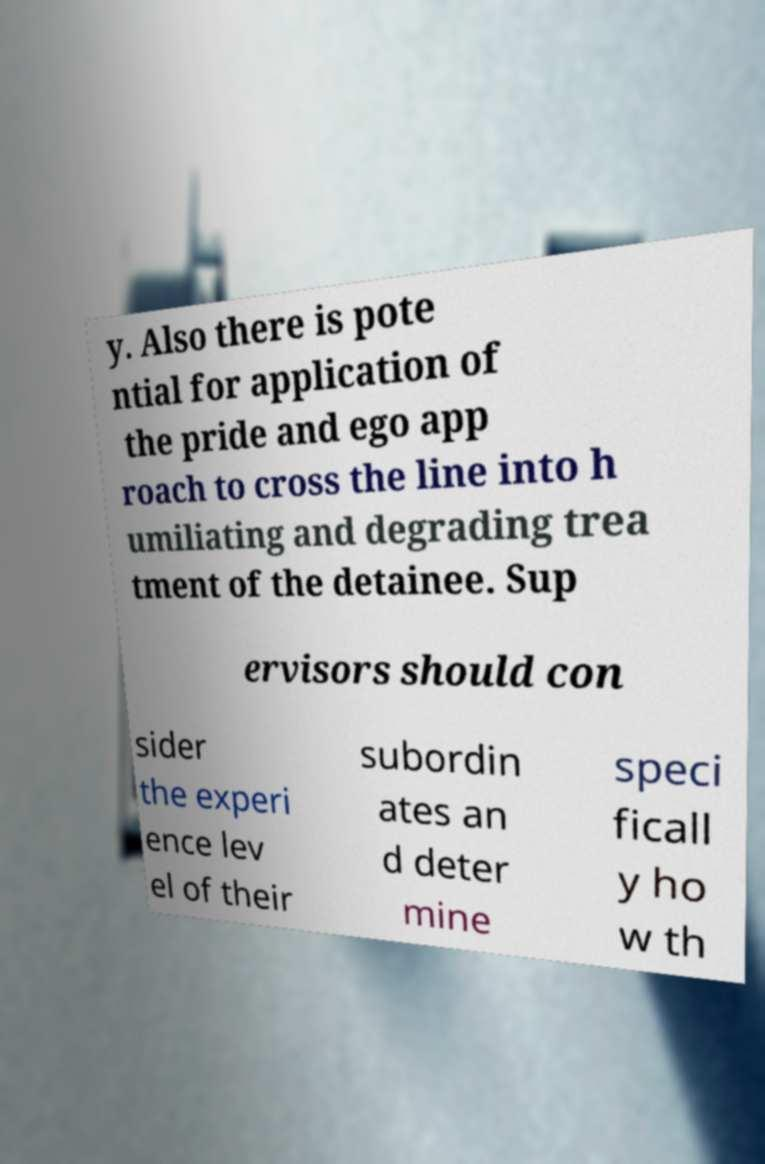I need the written content from this picture converted into text. Can you do that? y. Also there is pote ntial for application of the pride and ego app roach to cross the line into h umiliating and degrading trea tment of the detainee. Sup ervisors should con sider the experi ence lev el of their subordin ates an d deter mine speci ficall y ho w th 